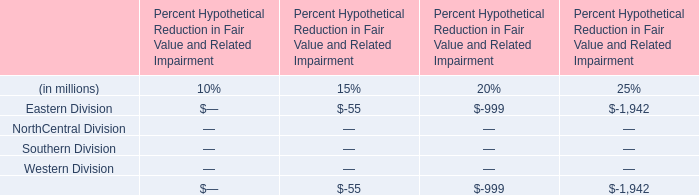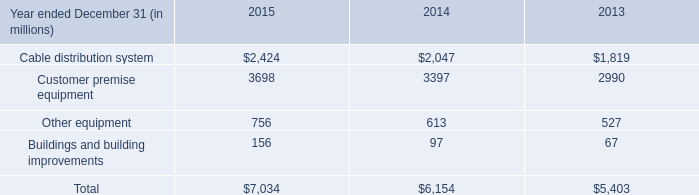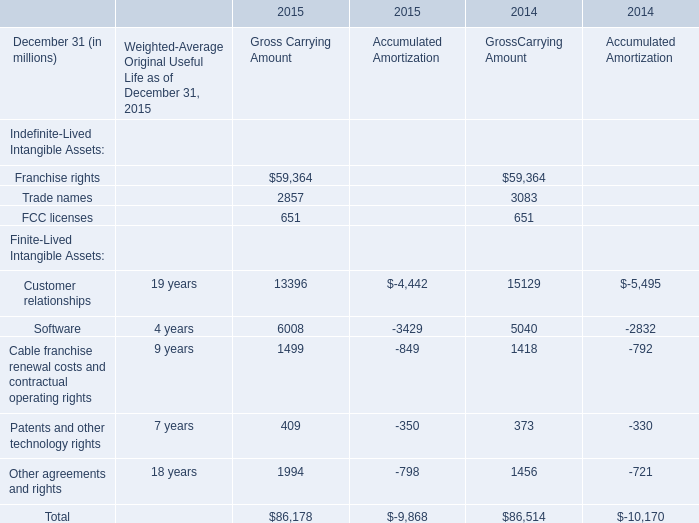What's the average of Franchise rights of 2015 Gross Carrying Amount, and Customer premise equipment of 2014 ? 
Computations: ((59364.0 + 3397.0) / 2)
Answer: 31380.5. 